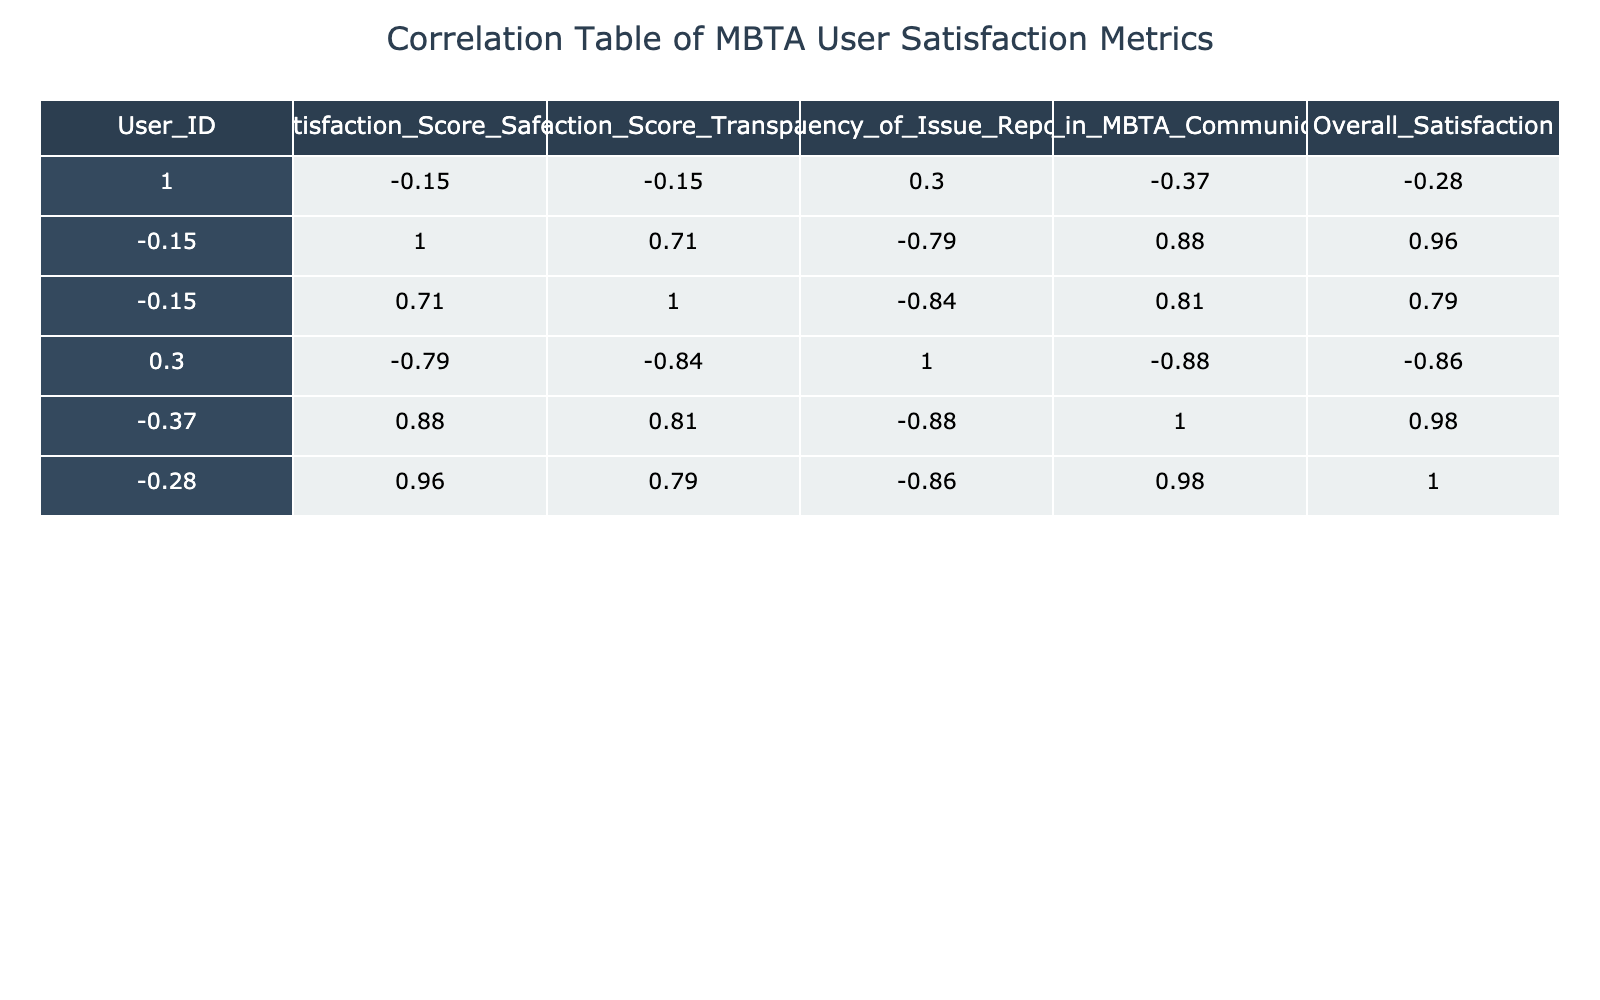What is the correlation between Satisfaction Score of Safety and Overall Satisfaction? From the correlation table, I find the value corresponding to Satisfaction Score of Safety and Overall Satisfaction, which is 0.87. This indicates a strong positive correlation, meaning as satisfaction with safety increases, overall satisfaction tends to increase as well.
Answer: 0.87 Is the Trust in MBTA Communication correlated with the Satisfaction Score of Transparency? Looking at the correlation value between Trust in MBTA Communication and Satisfaction Score of Transparency in the table, which is 0.42. This suggests a moderate positive correlation, meaning generally, as trust in communication increases, satisfaction with transparency tends to increase too.
Answer: 0.42 What is the average Satisfaction Score for Safety across all users? To find the average for Satisfaction Score of Safety, I sum all individual scores (4 + 3 + 5 + 2 + 4 + 3 + 5 + 2 + 4 + 3) = 36, then divide by the number of users which is 10. Hence, the average is 36/10 = 3.6.
Answer: 3.6 Is there a weak correlation between Frequency of Issue Reporting and Overall Satisfaction? Checking the correlation value for Frequency of Issue Reporting and Overall Satisfaction from the table, it shows -0.24. This indicates a weak negative correlation, suggesting that an increase in reporting issues may slightly lower overall satisfaction. Therefore, the statement is true.
Answer: Yes What is the difference between the highest and lowest Satisfaction Score of Transparency? From the table, the highest Satisfaction Score of Transparency is 5 (User_IDs 3 and 7) and the lowest is 2 (User_ID 4 and 10). Calculating the difference gives us 5 - 2 = 3.
Answer: 3 What is the correlation between Overall Satisfaction and Satisfaction Score of Safety? The correlation table shows that the correlation between Overall Satisfaction and Satisfaction Score of Safety is 0.87, indicating a strong positive relationship where higher safety scores yield higher overall satisfaction.
Answer: 0.87 Which user reported the highest level of Satisfaction Score for Transparency and what is that score? In reviewing the table, User_ID 3 and User_ID 7 both reported the highest Satisfaction Score for Transparency, which is 5.
Answer: 5 What is the average Trust in MBTA Communication across all user entries? Summing the Trust in MBTA Communication scores gives 4 + 3 + 5 + 2 + 4 + 3 + 5 + 2 + 4 + 1 = 33. Dividing by the number of users, which is 10, results in an average of 3.3.
Answer: 3.3 Is the correlation between Satisfaction Score of Safety and Trust in MBTA Communication strong? The correlation value between Satisfaction Score of Safety and Trust in MBTA Communication from the table is 0.54. Since this is greater than 0.5, we can state that there is a moderate positive correlation, rather than strong. Therefore, the statement is false.
Answer: No What is the correlation between Frequency of Issue Reporting and Satisfaction Score of Safety? The correlation table provides a value of -0.38 for Frequency of Issue Reporting and Satisfaction Score of Safety, indicating a moderate negative correlation where increased reporting of issues may relate to lower scores in safety satisfaction.
Answer: -0.38 